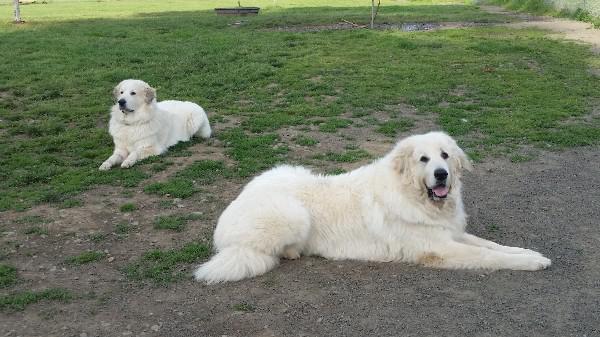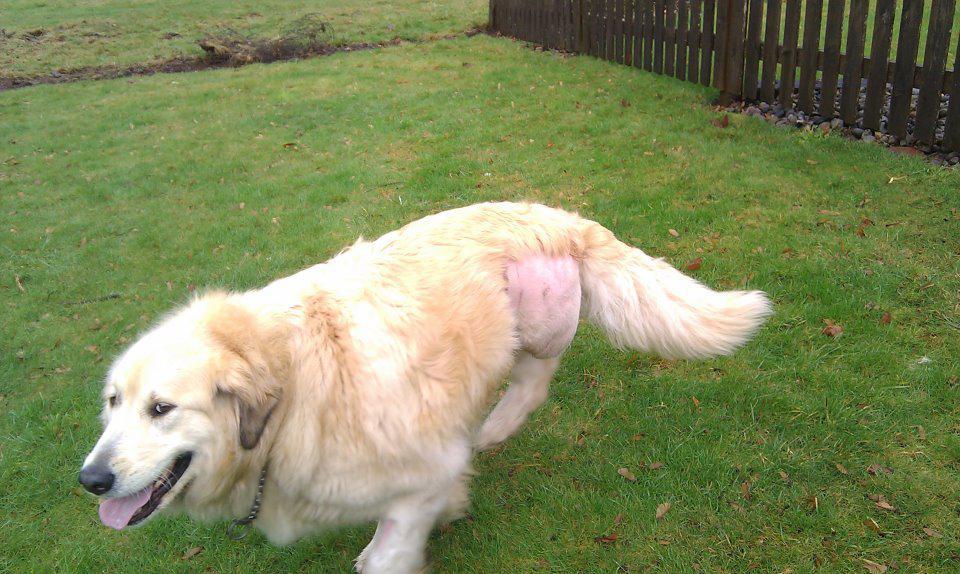The first image is the image on the left, the second image is the image on the right. Considering the images on both sides, is "There are at most two dogs." valid? Answer yes or no. No. The first image is the image on the left, the second image is the image on the right. Considering the images on both sides, is "The images together contain no more than two dogs." valid? Answer yes or no. No. 